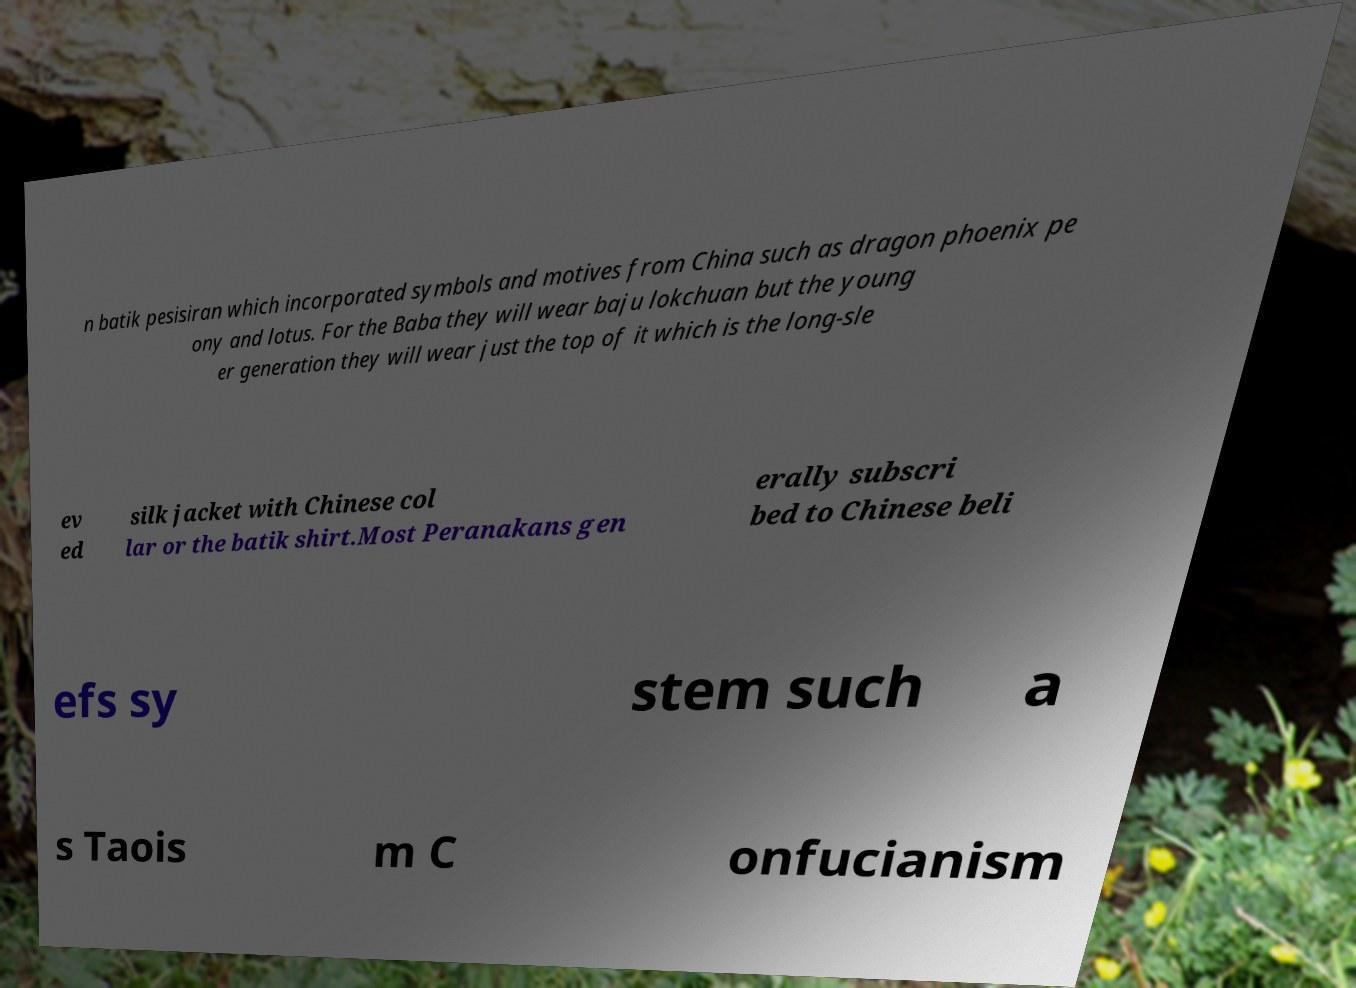I need the written content from this picture converted into text. Can you do that? n batik pesisiran which incorporated symbols and motives from China such as dragon phoenix pe ony and lotus. For the Baba they will wear baju lokchuan but the young er generation they will wear just the top of it which is the long-sle ev ed silk jacket with Chinese col lar or the batik shirt.Most Peranakans gen erally subscri bed to Chinese beli efs sy stem such a s Taois m C onfucianism 